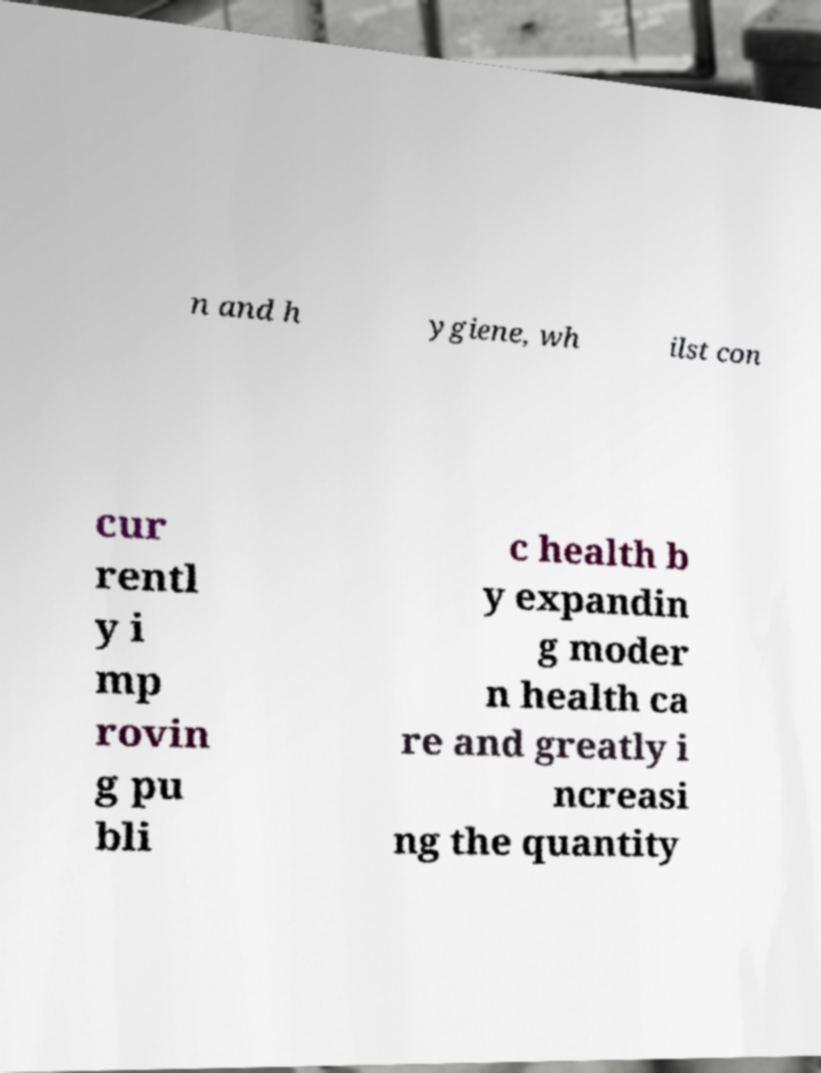What messages or text are displayed in this image? I need them in a readable, typed format. n and h ygiene, wh ilst con cur rentl y i mp rovin g pu bli c health b y expandin g moder n health ca re and greatly i ncreasi ng the quantity 